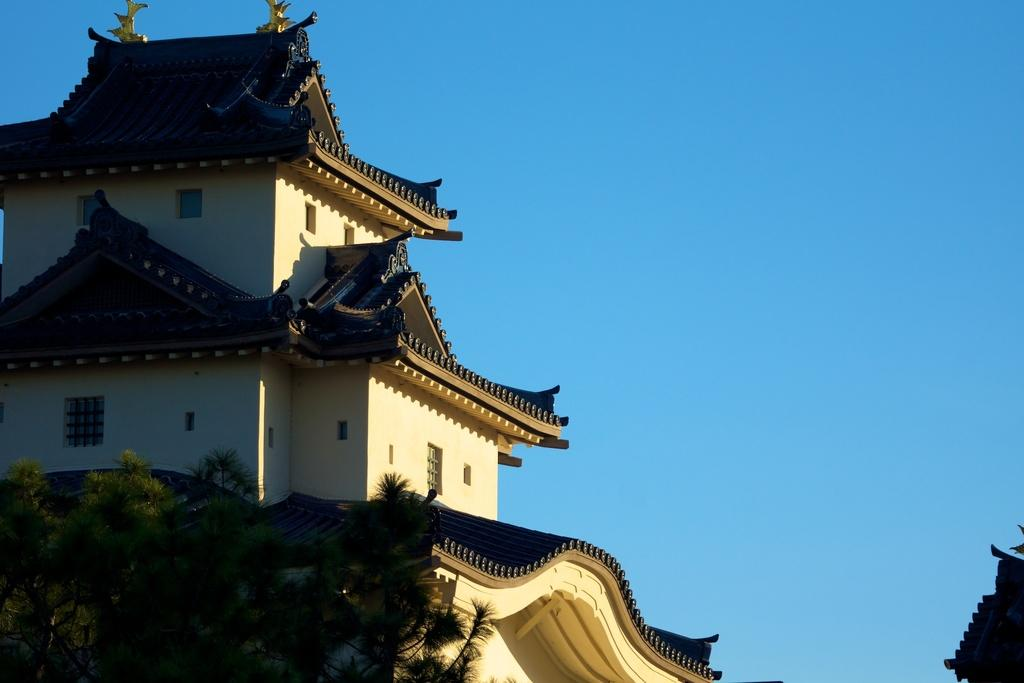What is located on the left side of the image? There is a tree on the left side of the image. What can be seen in the background of the image? There is a building in the background of the image. What features does the building have? The building has a roof and windows. What color is the sky in the image? The sky is blue in the image. How many sisters are sitting under the tree in the image? There are no sisters present in the image; it only features a tree, a building, and a blue sky. What type of cream is being used to paint the building in the image? There is no cream being used to paint the building in the image; the building's color is not mentioned in the provided facts. 